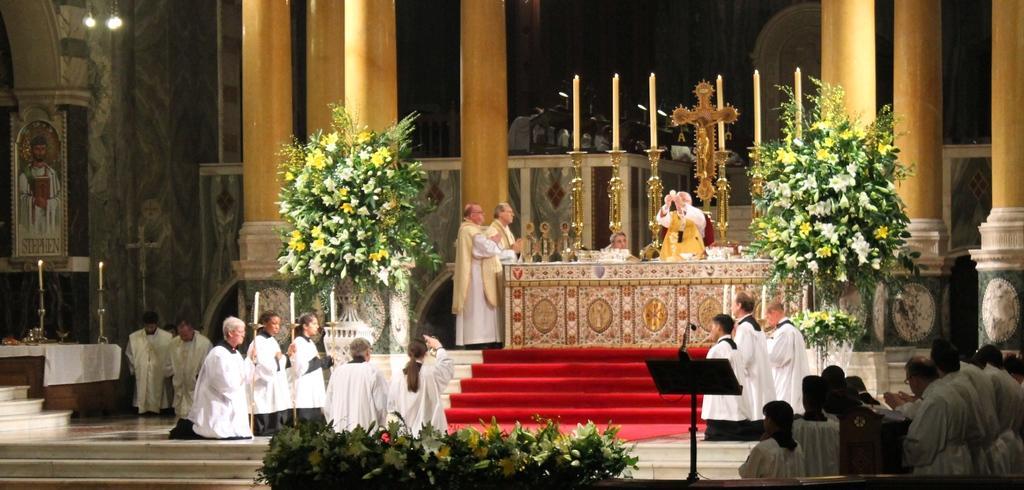Please provide a concise description of this image. In this picture I can observe some people sitting on the floor. I can observe some plants on either sides of the picture. There are some pillars which are in yellow color in this picture. In the background I can observe some candles and a cross in between the candles. 